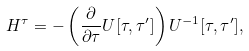<formula> <loc_0><loc_0><loc_500><loc_500>H ^ { \tau } = - \left ( \frac { \partial } { \partial \tau } U [ \tau , \tau ^ { \prime } ] \right ) U ^ { - 1 } [ \tau , \tau ^ { \prime } ] ,</formula> 